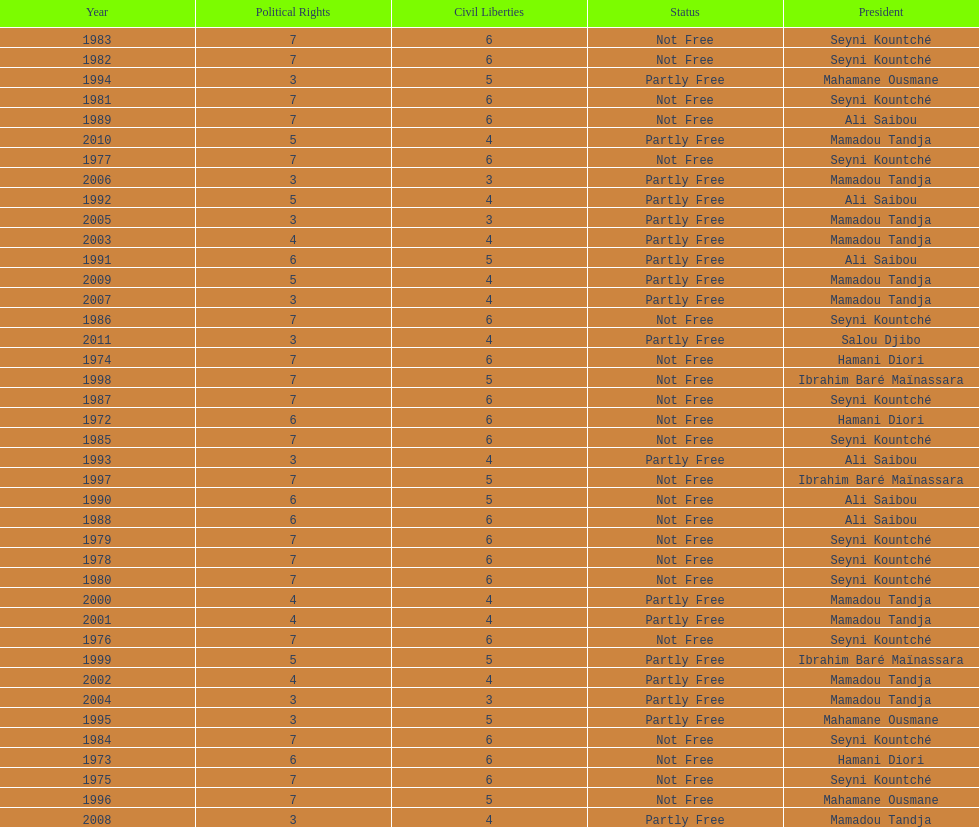Help me parse the entirety of this table. {'header': ['Year', 'Political Rights', 'Civil Liberties', 'Status', 'President'], 'rows': [['1983', '7', '6', 'Not Free', 'Seyni Kountché'], ['1982', '7', '6', 'Not Free', 'Seyni Kountché'], ['1994', '3', '5', 'Partly Free', 'Mahamane Ousmane'], ['1981', '7', '6', 'Not Free', 'Seyni Kountché'], ['1989', '7', '6', 'Not Free', 'Ali Saibou'], ['2010', '5', '4', 'Partly Free', 'Mamadou Tandja'], ['1977', '7', '6', 'Not Free', 'Seyni Kountché'], ['2006', '3', '3', 'Partly Free', 'Mamadou Tandja'], ['1992', '5', '4', 'Partly Free', 'Ali Saibou'], ['2005', '3', '3', 'Partly Free', 'Mamadou Tandja'], ['2003', '4', '4', 'Partly Free', 'Mamadou Tandja'], ['1991', '6', '5', 'Partly Free', 'Ali Saibou'], ['2009', '5', '4', 'Partly Free', 'Mamadou Tandja'], ['2007', '3', '4', 'Partly Free', 'Mamadou Tandja'], ['1986', '7', '6', 'Not Free', 'Seyni Kountché'], ['2011', '3', '4', 'Partly Free', 'Salou Djibo'], ['1974', '7', '6', 'Not Free', 'Hamani Diori'], ['1998', '7', '5', 'Not Free', 'Ibrahim Baré Maïnassara'], ['1987', '7', '6', 'Not Free', 'Seyni Kountché'], ['1972', '6', '6', 'Not Free', 'Hamani Diori'], ['1985', '7', '6', 'Not Free', 'Seyni Kountché'], ['1993', '3', '4', 'Partly Free', 'Ali Saibou'], ['1997', '7', '5', 'Not Free', 'Ibrahim Baré Maïnassara'], ['1990', '6', '5', 'Not Free', 'Ali Saibou'], ['1988', '6', '6', 'Not Free', 'Ali Saibou'], ['1979', '7', '6', 'Not Free', 'Seyni Kountché'], ['1978', '7', '6', 'Not Free', 'Seyni Kountché'], ['1980', '7', '6', 'Not Free', 'Seyni Kountché'], ['2000', '4', '4', 'Partly Free', 'Mamadou Tandja'], ['2001', '4', '4', 'Partly Free', 'Mamadou Tandja'], ['1976', '7', '6', 'Not Free', 'Seyni Kountché'], ['1999', '5', '5', 'Partly Free', 'Ibrahim Baré Maïnassara'], ['2002', '4', '4', 'Partly Free', 'Mamadou Tandja'], ['2004', '3', '3', 'Partly Free', 'Mamadou Tandja'], ['1995', '3', '5', 'Partly Free', 'Mahamane Ousmane'], ['1984', '7', '6', 'Not Free', 'Seyni Kountché'], ['1973', '6', '6', 'Not Free', 'Hamani Diori'], ['1975', '7', '6', 'Not Free', 'Seyni Kountché'], ['1996', '7', '5', 'Not Free', 'Mahamane Ousmane'], ['2008', '3', '4', 'Partly Free', 'Mamadou Tandja']]} How many years was it before the first partly free status? 18. 